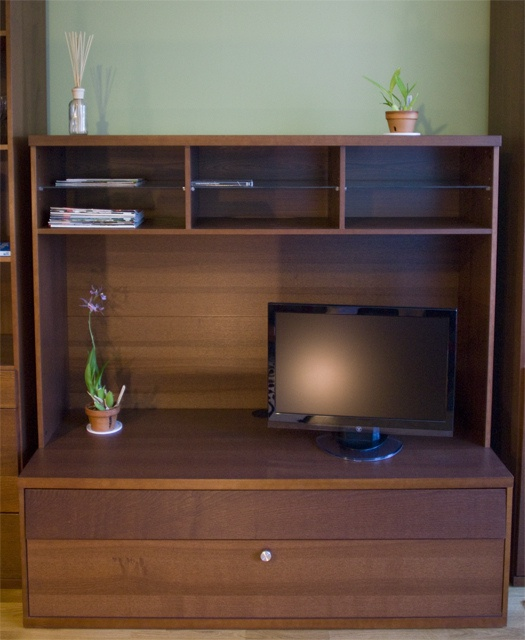Describe the objects in this image and their specific colors. I can see tv in black, brown, and gray tones, potted plant in black, gray, darkgreen, and maroon tones, book in black, darkgray, and gray tones, potted plant in black, darkgray, olive, and gray tones, and book in black and gray tones in this image. 